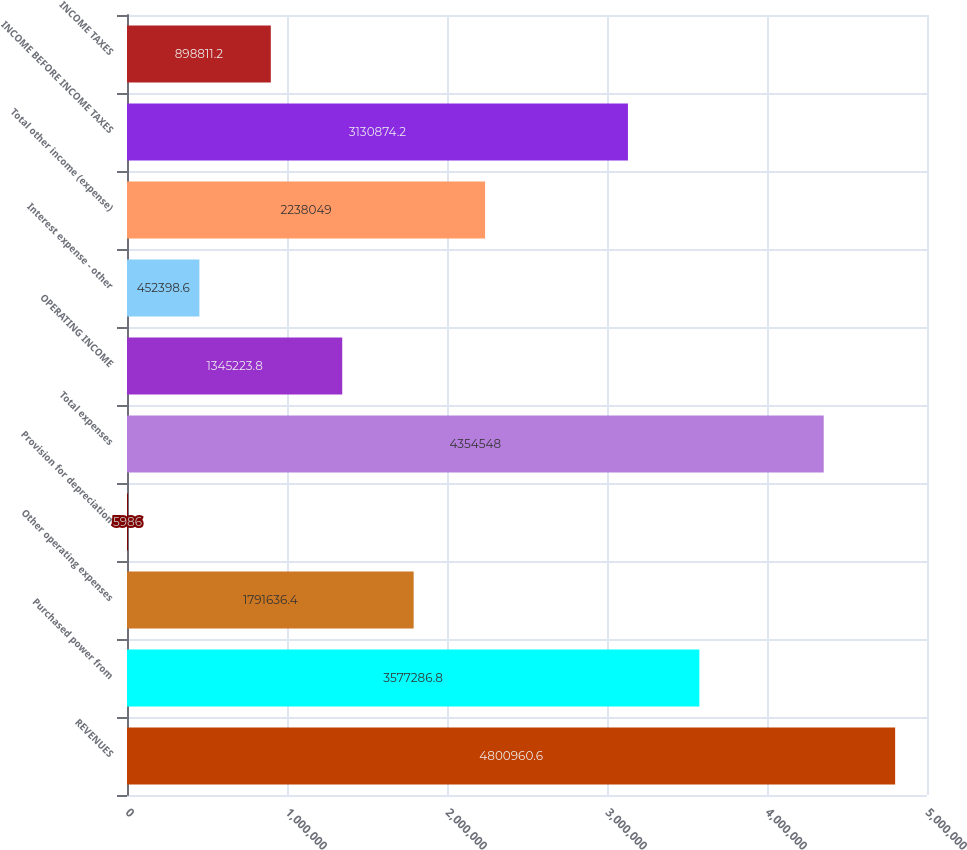<chart> <loc_0><loc_0><loc_500><loc_500><bar_chart><fcel>REVENUES<fcel>Purchased power from<fcel>Other operating expenses<fcel>Provision for depreciation<fcel>Total expenses<fcel>OPERATING INCOME<fcel>Interest expense - other<fcel>Total other income (expense)<fcel>INCOME BEFORE INCOME TAXES<fcel>INCOME TAXES<nl><fcel>4.80096e+06<fcel>3.57729e+06<fcel>1.79164e+06<fcel>5986<fcel>4.35455e+06<fcel>1.34522e+06<fcel>452399<fcel>2.23805e+06<fcel>3.13087e+06<fcel>898811<nl></chart> 